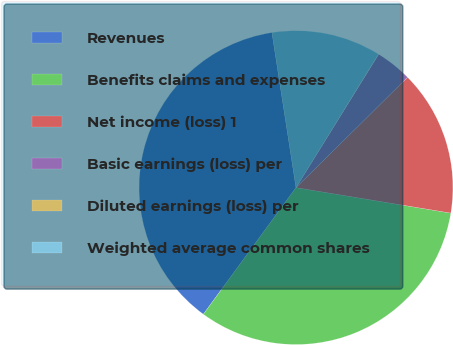<chart> <loc_0><loc_0><loc_500><loc_500><pie_chart><fcel>Revenues<fcel>Benefits claims and expenses<fcel>Net income (loss) 1<fcel>Basic earnings (loss) per<fcel>Diluted earnings (loss) per<fcel>Weighted average common shares<nl><fcel>37.5%<fcel>32.46%<fcel>15.01%<fcel>3.76%<fcel>0.02%<fcel>11.26%<nl></chart> 